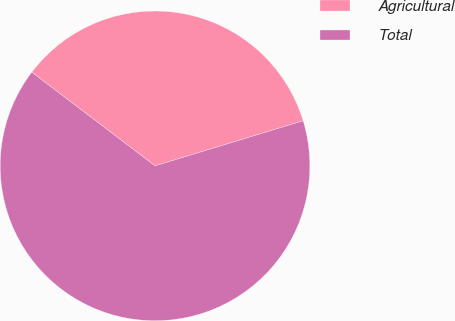<chart> <loc_0><loc_0><loc_500><loc_500><pie_chart><fcel>Agricultural<fcel>Total<nl><fcel>34.95%<fcel>65.05%<nl></chart> 